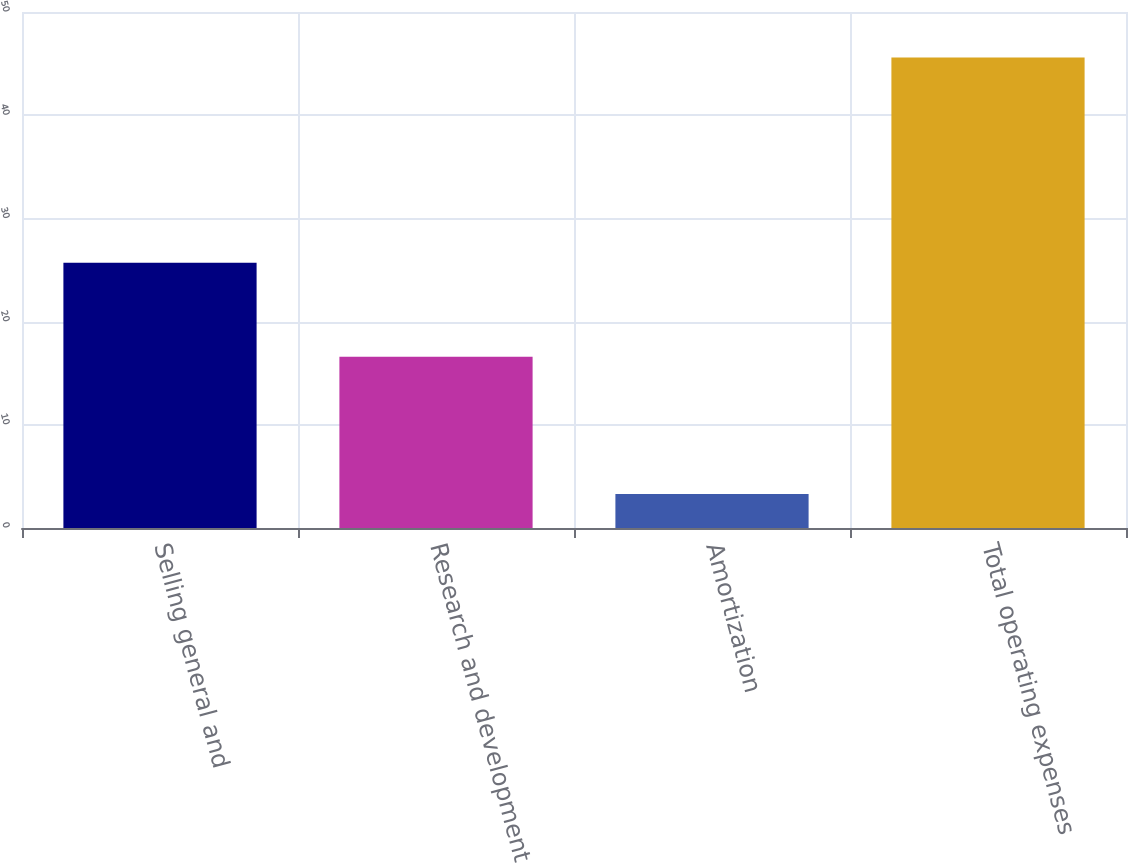Convert chart. <chart><loc_0><loc_0><loc_500><loc_500><bar_chart><fcel>Selling general and<fcel>Research and development<fcel>Amortization<fcel>Total operating expenses<nl><fcel>25.7<fcel>16.6<fcel>3.3<fcel>45.6<nl></chart> 